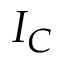Convert formula to latex. <formula><loc_0><loc_0><loc_500><loc_500>I _ { C }</formula> 